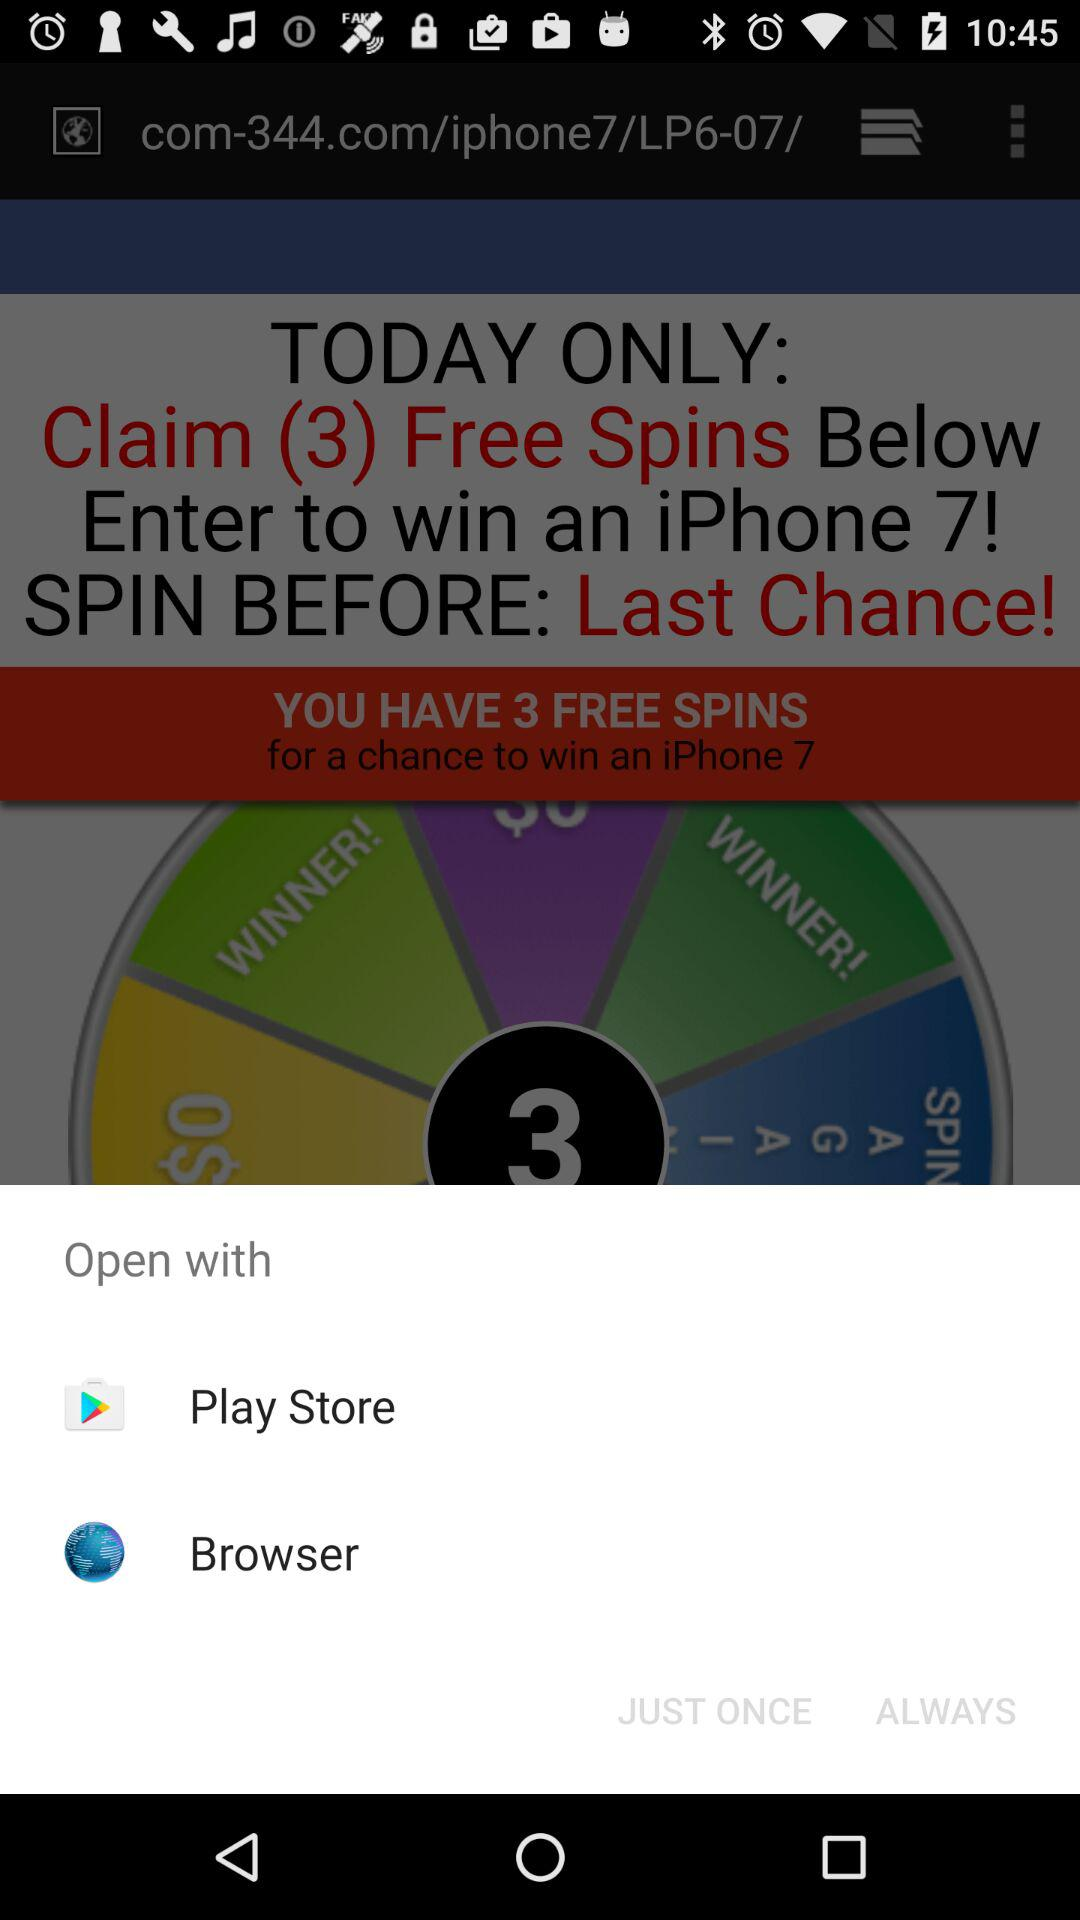How many free spins do I have?
Answer the question using a single word or phrase. 3 